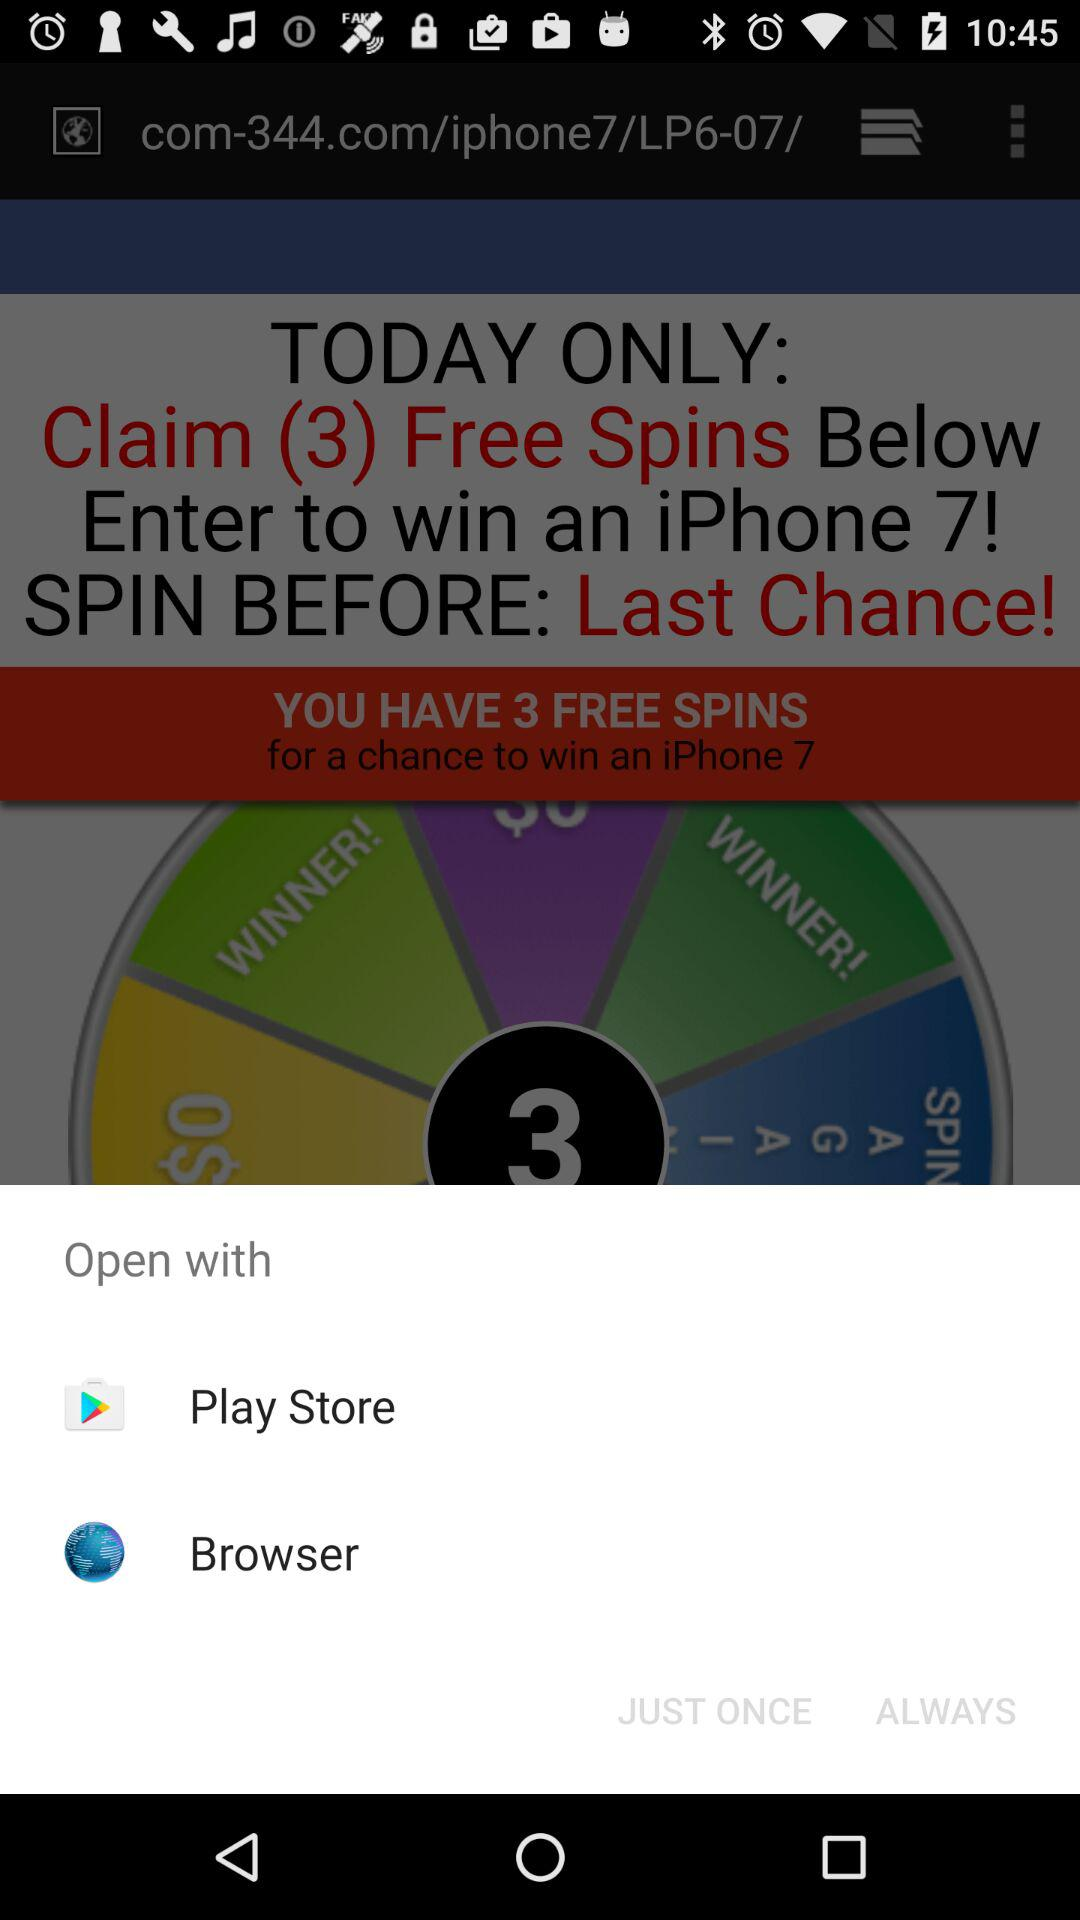How many free spins do I have?
Answer the question using a single word or phrase. 3 